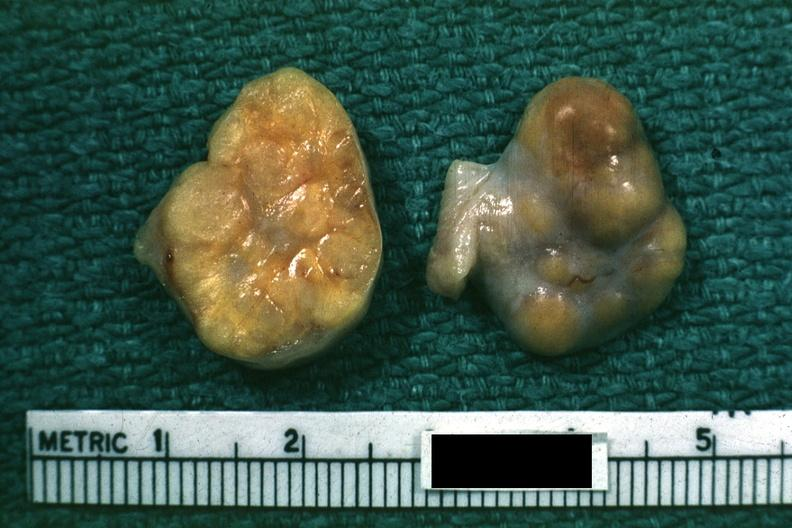what is present?
Answer the question using a single word or phrase. Ovary 